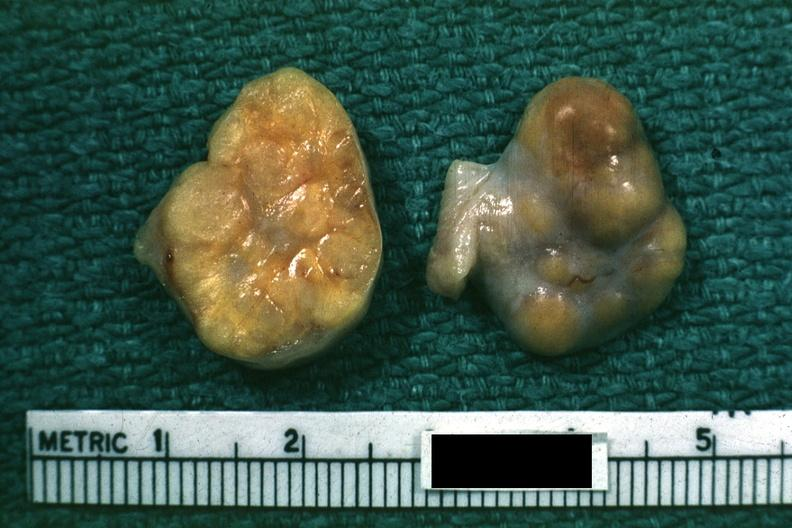what is present?
Answer the question using a single word or phrase. Ovary 